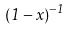Convert formula to latex. <formula><loc_0><loc_0><loc_500><loc_500>( 1 - x ) ^ { - 1 }</formula> 